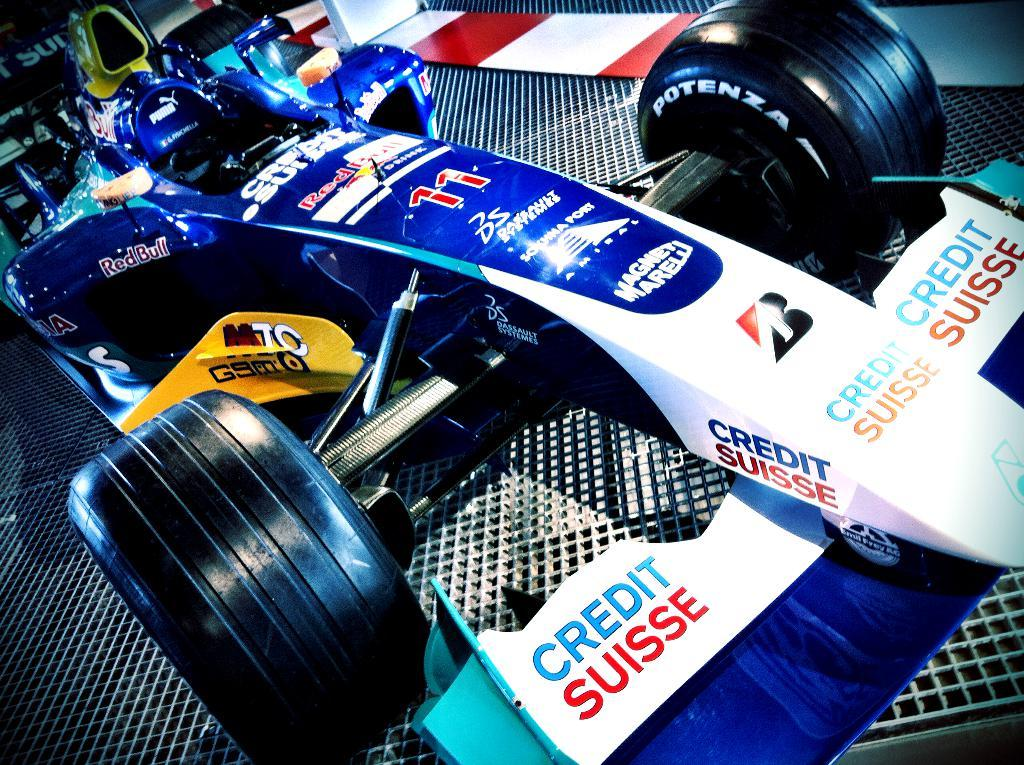What type of vehicle is in the image? There is a sports vehicle in the image. Where is the vehicle located in the image? The vehicle is in the center of the image. What can be seen on the surface of the vehicle? There is writing on the vehicle and other objects visible on it. How many clovers are growing on the hood of the vehicle in the image? There are no clovers visible on the vehicle in the image. 